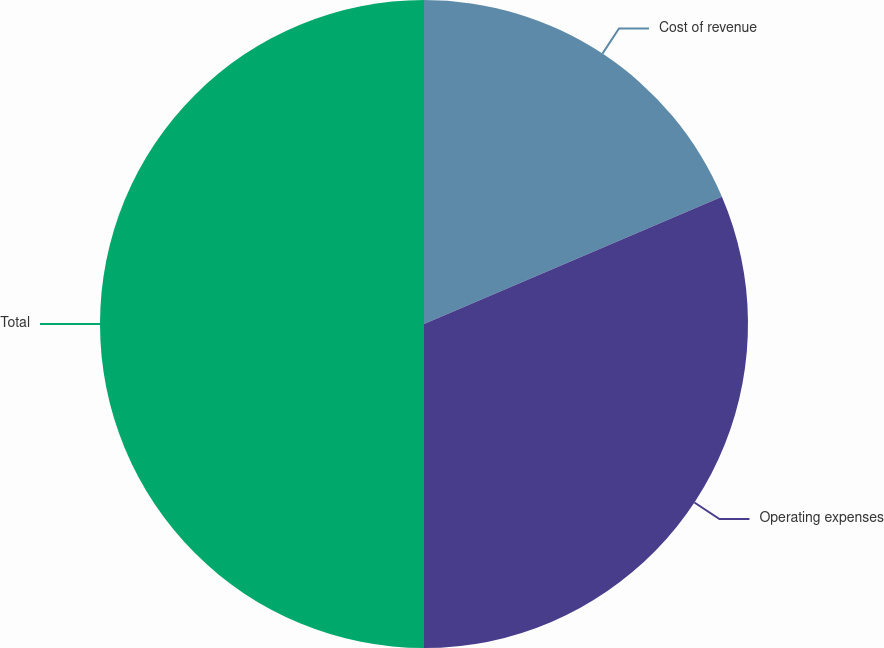<chart> <loc_0><loc_0><loc_500><loc_500><pie_chart><fcel>Cost of revenue<fcel>Operating expenses<fcel>Total<nl><fcel>18.57%<fcel>31.43%<fcel>50.0%<nl></chart> 